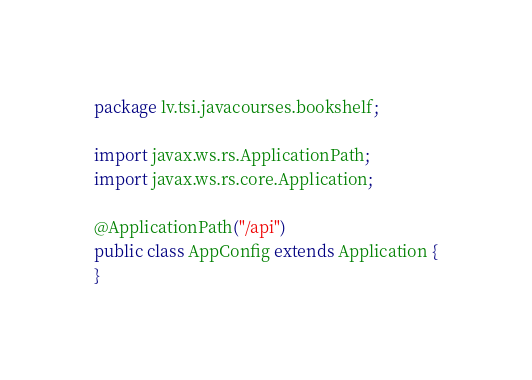<code> <loc_0><loc_0><loc_500><loc_500><_Java_>package lv.tsi.javacourses.bookshelf;

import javax.ws.rs.ApplicationPath;
import javax.ws.rs.core.Application;

@ApplicationPath("/api")
public class AppConfig extends Application {
}
</code> 